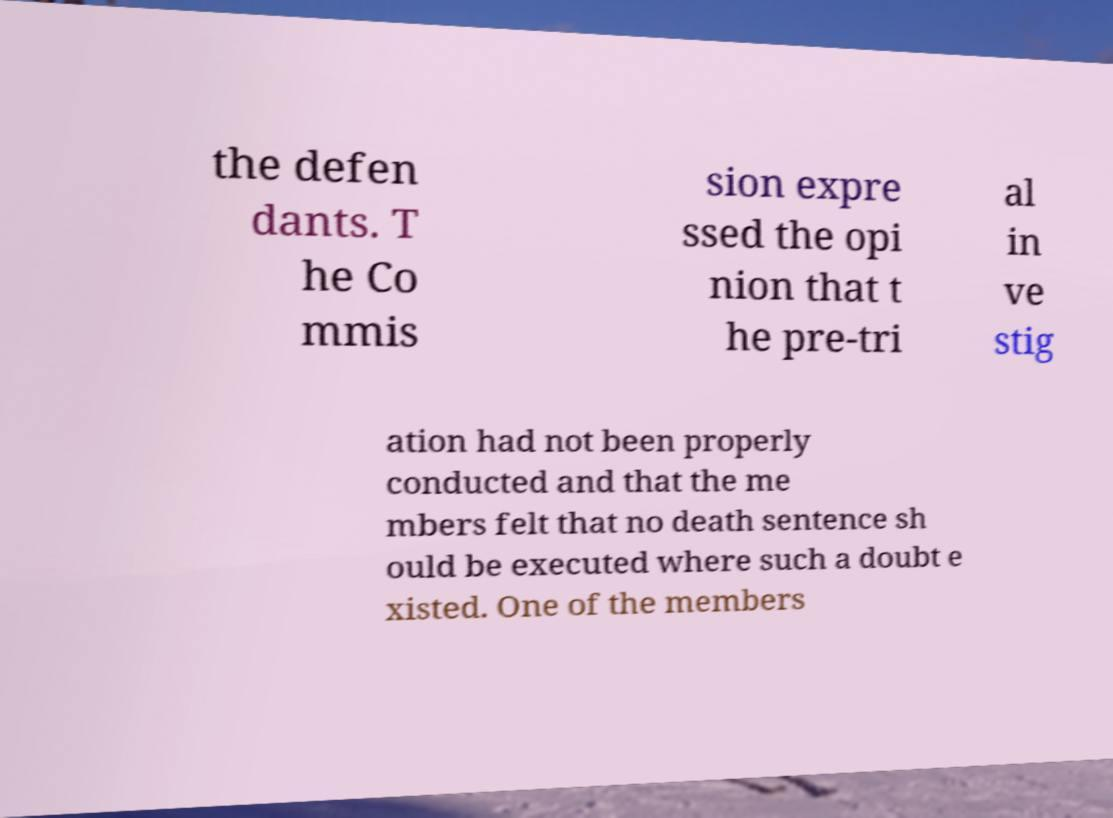There's text embedded in this image that I need extracted. Can you transcribe it verbatim? the defen dants. T he Co mmis sion expre ssed the opi nion that t he pre-tri al in ve stig ation had not been properly conducted and that the me mbers felt that no death sentence sh ould be executed where such a doubt e xisted. One of the members 